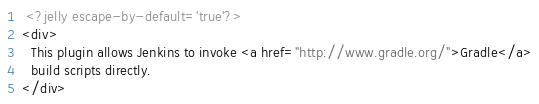<code> <loc_0><loc_0><loc_500><loc_500><_XML_> <?jelly escape-by-default='true'?>
<div>
  This plugin allows Jenkins to invoke <a href="http://www.gradle.org/">Gradle</a>
  build scripts directly.
</div></code> 